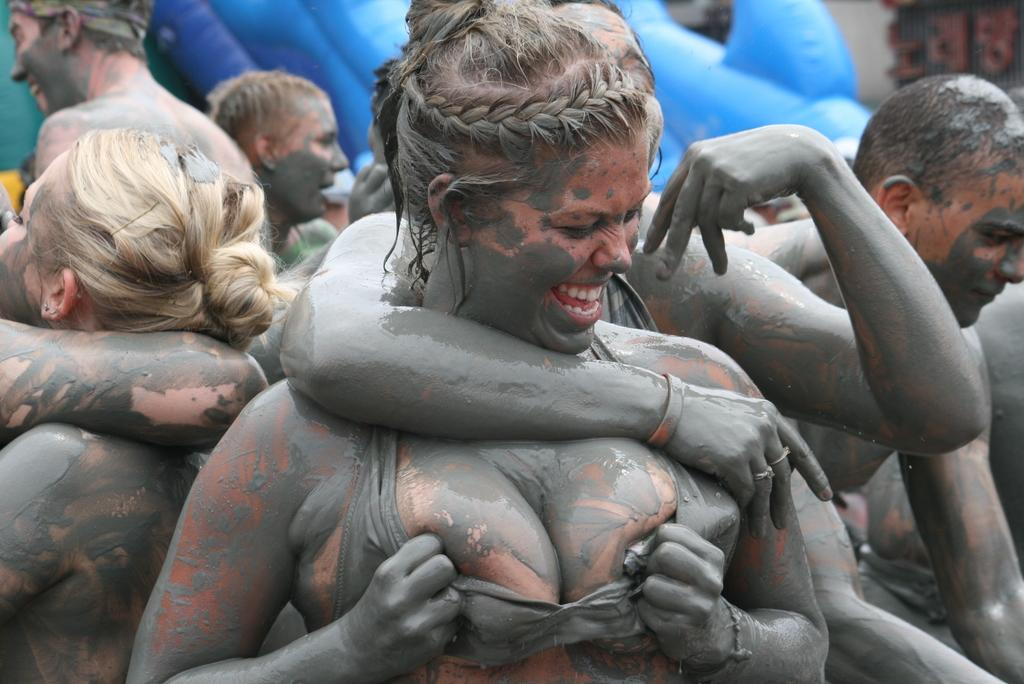How many people are in the image? There are persons in the image, but the exact number is not specified. What are the persons doing in the image? The persons are standing and hugging each other. What type of tomatoes can be seen growing on the dock in the image? There is no dock or tomatoes present in the image; it features persons standing and hugging each other. 